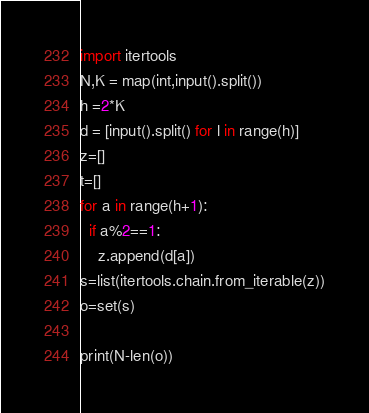<code> <loc_0><loc_0><loc_500><loc_500><_Python_>import itertools
N,K = map(int,input().split())
h =2*K
d = [input().split() for l in range(h)]
z=[]
t=[]
for a in range(h+1):
  if a%2==1:
    z.append(d[a])
s=list(itertools.chain.from_iterable(z))
o=set(s)

print(N-len(o))</code> 